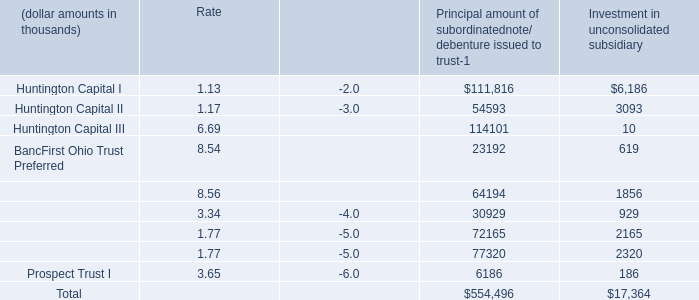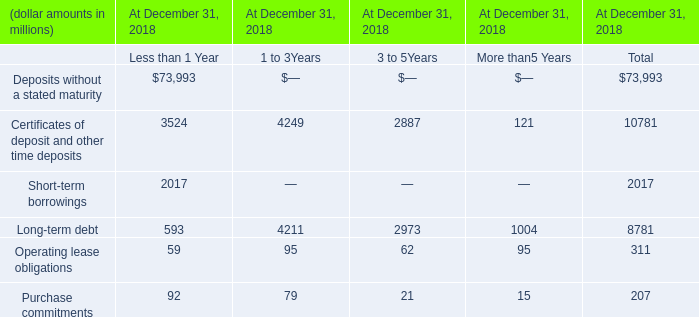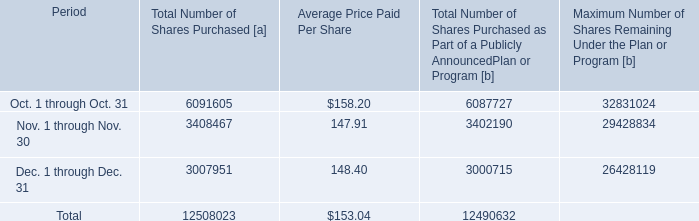What was the total amount of Principal amount of subordinatednote/ debenture issued to trust-1 for Principal amount ? (in thousand) 
Computations: ((((((((111816 + 54593) + 114101) + 23192) + 64194) + 72165) + 30929) + 77320) + 6186)
Answer: 554496.0. 